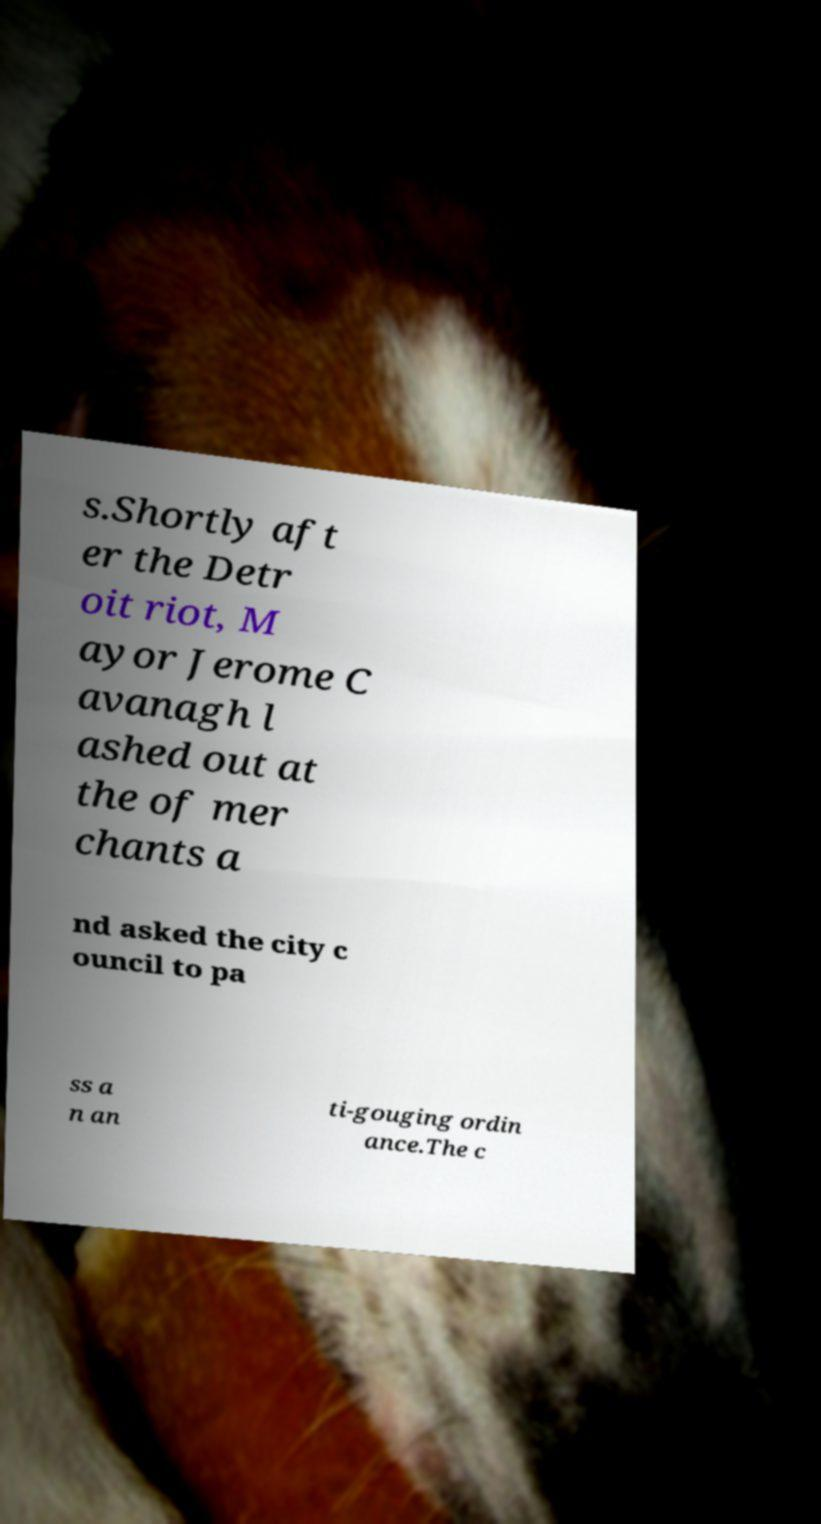For documentation purposes, I need the text within this image transcribed. Could you provide that? s.Shortly aft er the Detr oit riot, M ayor Jerome C avanagh l ashed out at the of mer chants a nd asked the city c ouncil to pa ss a n an ti-gouging ordin ance.The c 